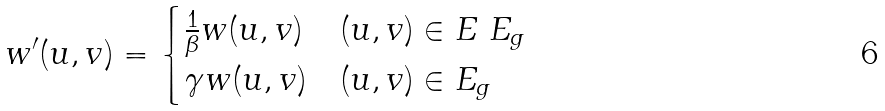Convert formula to latex. <formula><loc_0><loc_0><loc_500><loc_500>w ^ { \prime } ( u , v ) = \begin{cases} \frac { 1 } { \beta } w ( u , v ) & ( u , v ) \in E \ E _ { g } \\ \gamma w ( u , v ) & ( u , v ) \in E _ { g } \end{cases}</formula> 